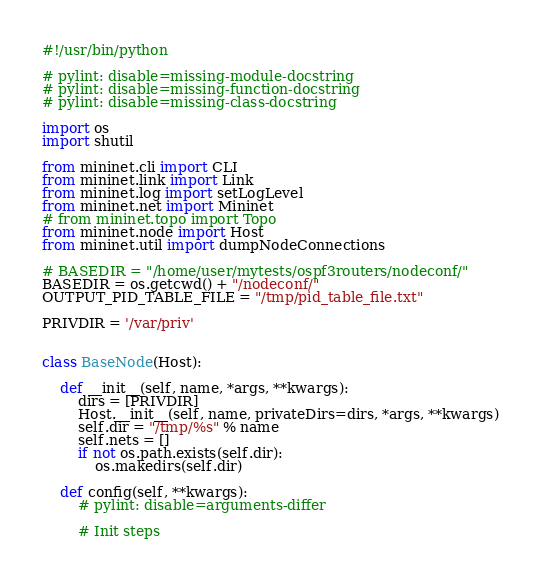<code> <loc_0><loc_0><loc_500><loc_500><_Python_>#!/usr/bin/python

# pylint: disable=missing-module-docstring
# pylint: disable=missing-function-docstring
# pylint: disable=missing-class-docstring

import os
import shutil

from mininet.cli import CLI
from mininet.link import Link
from mininet.log import setLogLevel
from mininet.net import Mininet
# from mininet.topo import Topo
from mininet.node import Host
from mininet.util import dumpNodeConnections

# BASEDIR = "/home/user/mytests/ospf3routers/nodeconf/"
BASEDIR = os.getcwd() + "/nodeconf/"
OUTPUT_PID_TABLE_FILE = "/tmp/pid_table_file.txt"

PRIVDIR = '/var/priv'


class BaseNode(Host):

    def __init__(self, name, *args, **kwargs):
        dirs = [PRIVDIR]
        Host.__init__(self, name, privateDirs=dirs, *args, **kwargs)
        self.dir = "/tmp/%s" % name
        self.nets = []
        if not os.path.exists(self.dir):
            os.makedirs(self.dir)

    def config(self, **kwargs):
        # pylint: disable=arguments-differ

        # Init steps</code> 